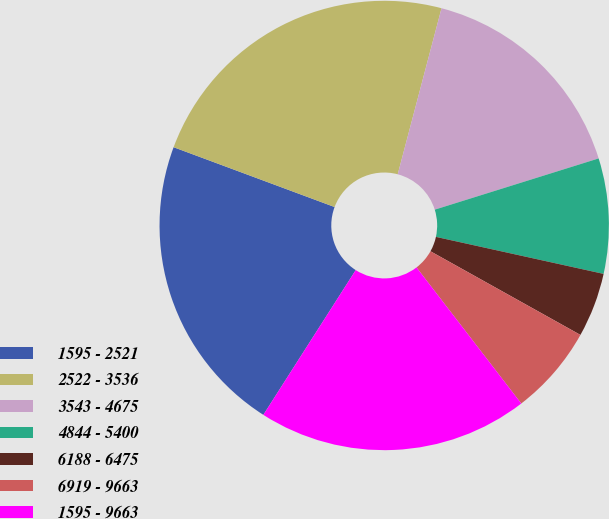Convert chart to OTSL. <chart><loc_0><loc_0><loc_500><loc_500><pie_chart><fcel>1595 - 2521<fcel>2522 - 3536<fcel>3543 - 4675<fcel>4844 - 5400<fcel>6188 - 6475<fcel>6919 - 9663<fcel>1595 - 9663<nl><fcel>21.62%<fcel>23.44%<fcel>16.07%<fcel>8.28%<fcel>4.64%<fcel>6.46%<fcel>19.48%<nl></chart> 